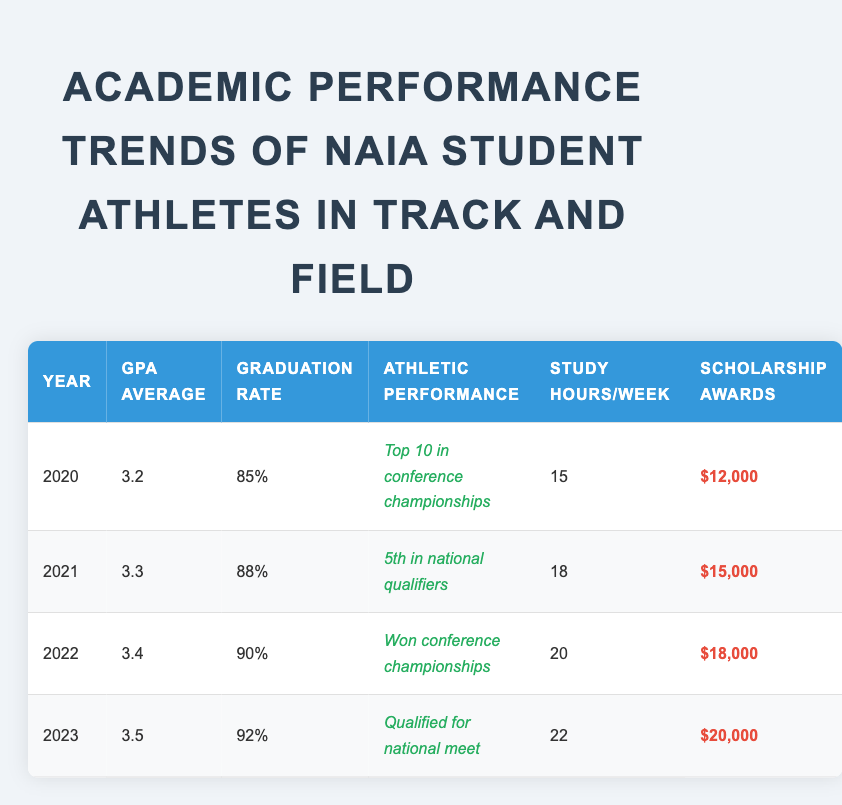What was the GPA average in 2022? The GPA average listed for the year 2022 is 3.4.
Answer: 3.4 What was the graduation rate in 2021? The graduation rate shown for 2021 is 88%.
Answer: 88% How many scholarship awards were given in 2023? The scholarship awards for 2023 are indicated as $20,000.
Answer: $20,000 What is the difference in GPA average between 2020 and 2023? The GPA average for 2020 is 3.2 and for 2023 is 3.5. The difference is 3.5 - 3.2 = 0.3.
Answer: 0.3 What was the highest graduation rate achieved during these years? The graduation rates for each year are 85%, 88%, 90%, and 92%. The highest rate is 92% in 2023.
Answer: 92% Was there an increase in study hours per week from 2020 to 2022? In 2020, study hours were 15, and in 2022, they were 20. This shows an increase from 15 to 20 hours.
Answer: Yes Which year had the lowest scholarship awards, and what was the amount? The year with the lowest scholarship awards is 2020, where the amount is $12,000.
Answer: 2020, $12,000 What are the average study hours per week from 2020 to 2023? The study hours per week for the years are 15, 18, 20, and 22 respectively. The total is 15 + 18 + 20 + 22 = 75. To find the average, divide by 4, which is 75 / 4 = 18.75.
Answer: 18.75 Was the athletic performance in 2022 better than in 2021? In 2022, the athletic performance was "Won conference championships" compared to "5th in national qualifiers" in 2021, indicating better performance in 2022.
Answer: Yes How much did the scholarship awards increase from 2020 to 2023? The scholarship awards increased from $12,000 in 2020 to $20,000 in 2023, which is an increase of $20,000 - $12,000 = $8,000.
Answer: $8,000 